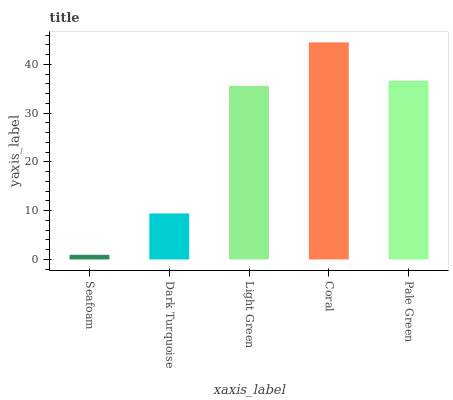Is Dark Turquoise the minimum?
Answer yes or no. No. Is Dark Turquoise the maximum?
Answer yes or no. No. Is Dark Turquoise greater than Seafoam?
Answer yes or no. Yes. Is Seafoam less than Dark Turquoise?
Answer yes or no. Yes. Is Seafoam greater than Dark Turquoise?
Answer yes or no. No. Is Dark Turquoise less than Seafoam?
Answer yes or no. No. Is Light Green the high median?
Answer yes or no. Yes. Is Light Green the low median?
Answer yes or no. Yes. Is Coral the high median?
Answer yes or no. No. Is Dark Turquoise the low median?
Answer yes or no. No. 